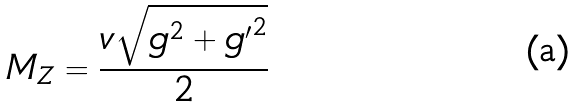<formula> <loc_0><loc_0><loc_500><loc_500>M _ { Z } = \frac { v \sqrt { g ^ { 2 } + { g ^ { \prime } } ^ { 2 } } } { 2 }</formula> 